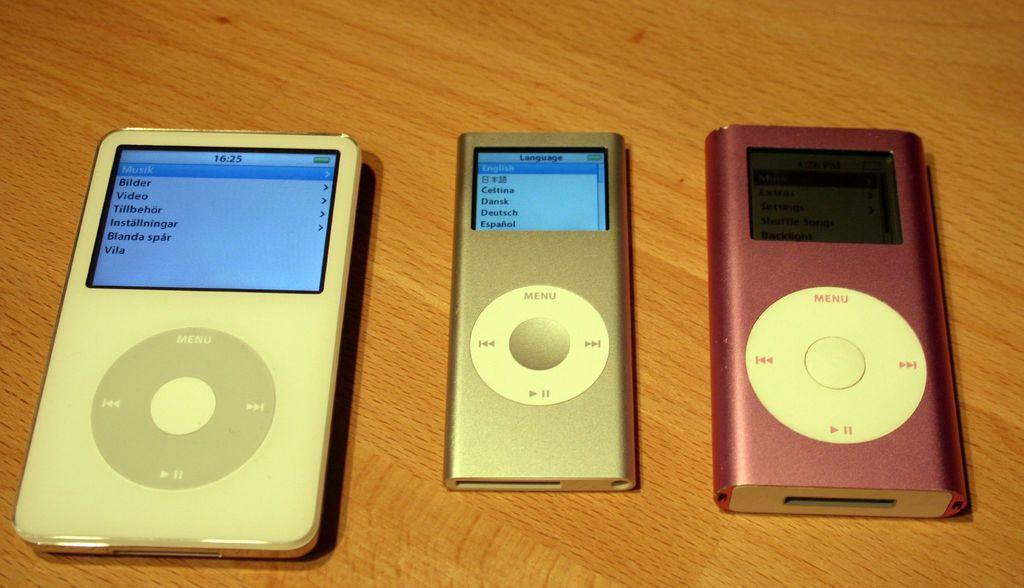What type of electronic device is visible in the image? There are airpods in the image. What surface are the airpods resting on? The airpods are on a wooden surface. What type of knee injury is the woman experiencing in the image? There is no woman or knee injury present in the image; it only features airpods on a wooden surface. 